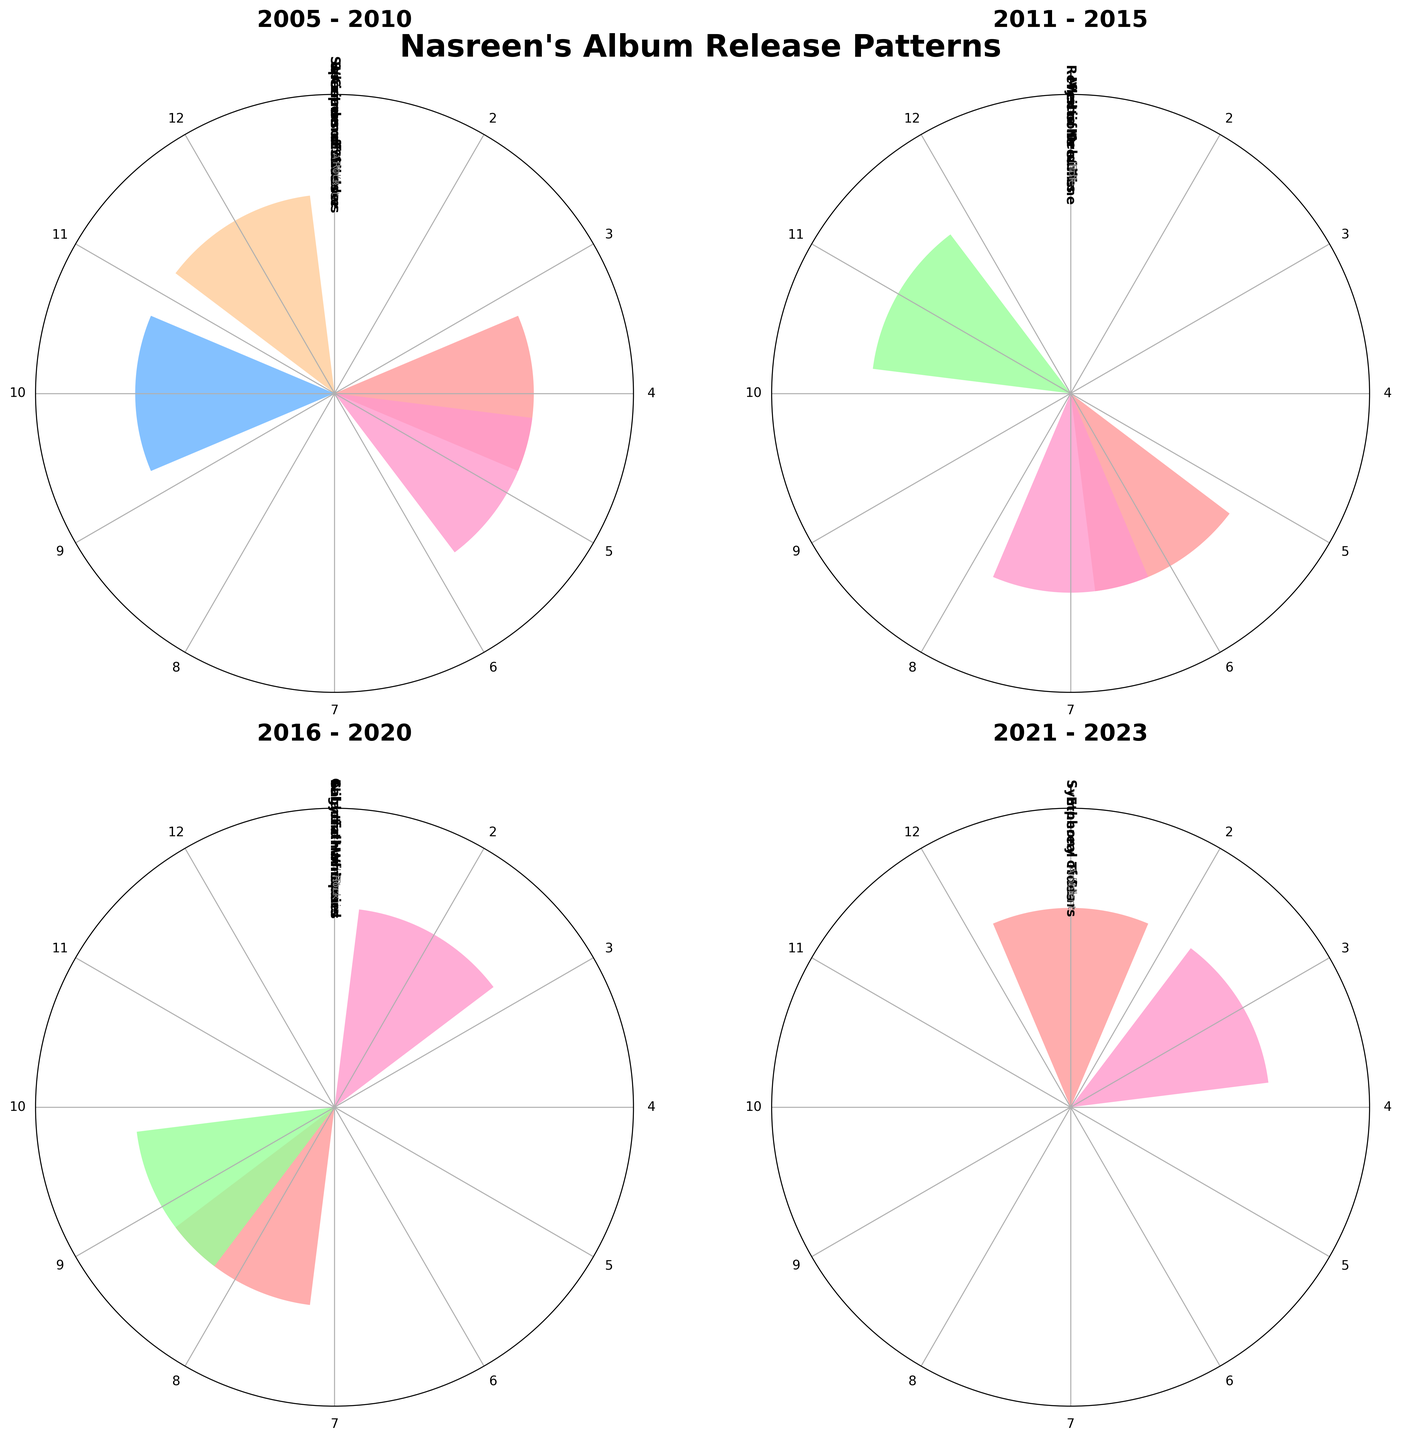Which year range has the most album releases? To determine the year range with the most album releases, observe each subplot and count the albums in each. The subplot for 2016-2020 contains 4 albums, which is the highest count.
Answer: 2016-2020 How many albums were released in the year range 2005-2010? Look at the subplot titled "2005 - 2010" and count the number of albums shown. There are 4 albums released in this period.
Answer: 4 In which month of the year range 2011-2015 were the most albums released? Examine the subplot titled "2011 - 2015" and count the bars corresponding to each month. June has the most album releases with 1 album.
Answer: June What is the genre of the album "Nightfall Whispers" released in 2020? Find the subplot for the year range 2016-2020, locate the album "Nightfall Whispers" and read the genre text associated with it, which is "Rock".
Answer: Rock Did Nasreen release any albums in February across all year ranges? Check each subplot for any bar corresponding to February (approximately 30 degrees from the top). The album "Ethereal Tides" is shown in February 2023.
Answer: Yes Which year range includes the album "Mystic Melodies"? Locate the album "Mystic Melodies" within the subplots. It is in the subplot titled "2011 - 2015" indicating it was released in that range.
Answer: 2011-2015 Compare the number of Pop albums released between 2005-2010 and 2016-2020. Which period has more? Count the Pop albums in each relevant subplot. In 2005-2010, there is 1 Pop album ("Whispers of Wonder"), and in 2016-2020, there is 1 Pop album ("Galactic Harmonies"). Both periods have the same number of Pop albums.
Answer: Equal What is the average number of albums released per year from 2016 to 2020? Four albums were released in the five-year period from 2016 to 2020. The average number of albums per year is 4/5 = 0.8.
Answer: 0.8 Which genre is most common in the year range 2005-2010? Look at the subplot for 2005-2010 and identify the genres of the albums. Pop appears twice, which is the most frequent genre within that period.
Answer: Pop 